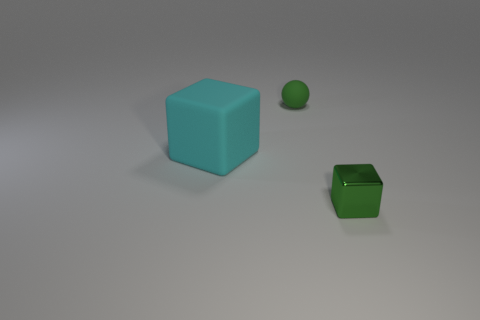Add 3 green matte spheres. How many objects exist? 6 Subtract all spheres. How many objects are left? 2 Subtract all tiny green objects. Subtract all small green balls. How many objects are left? 0 Add 3 tiny green blocks. How many tiny green blocks are left? 4 Add 1 green things. How many green things exist? 3 Subtract 0 brown cylinders. How many objects are left? 3 